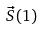<formula> <loc_0><loc_0><loc_500><loc_500>\vec { S } ( 1 )</formula> 